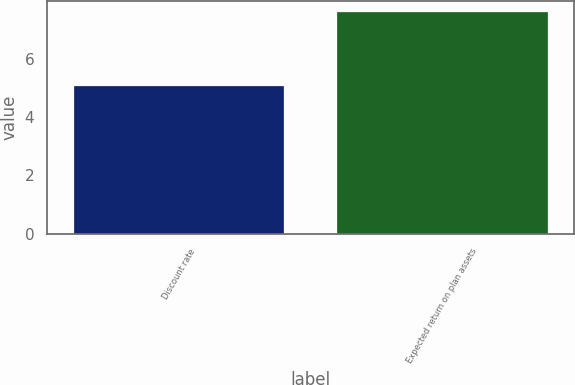Convert chart. <chart><loc_0><loc_0><loc_500><loc_500><bar_chart><fcel>Discount rate<fcel>Expected return on plan assets<nl><fcel>5.05<fcel>7.6<nl></chart> 